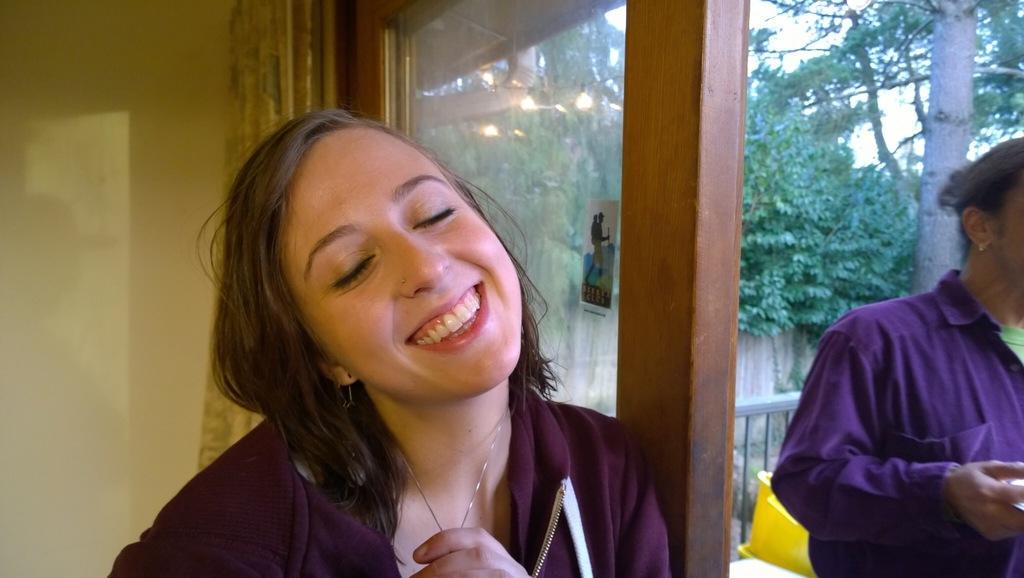How would you summarize this image in a sentence or two? In this picture I can see couple of them standing I can see trees and a curtain. 